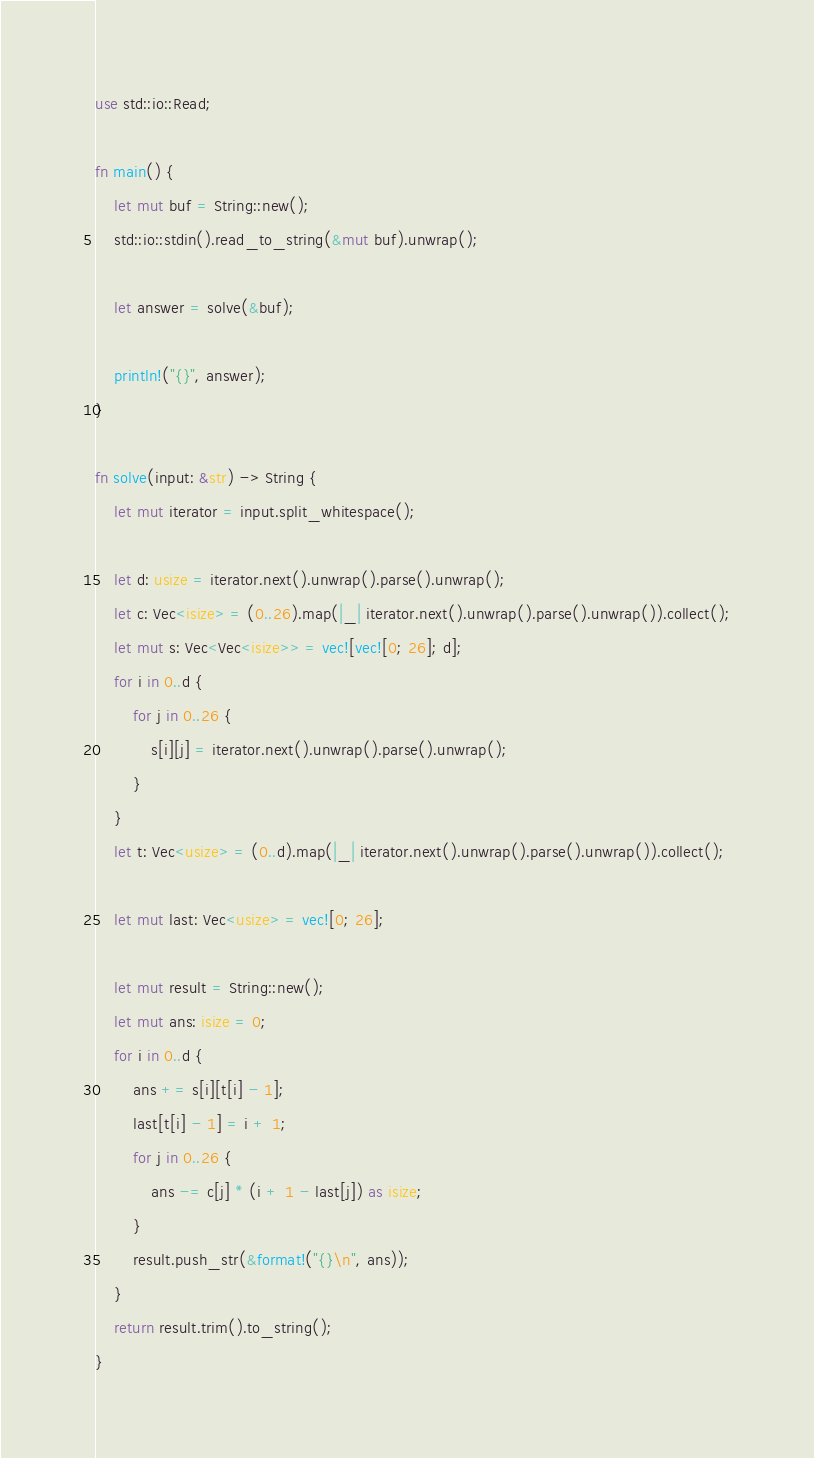Convert code to text. <code><loc_0><loc_0><loc_500><loc_500><_Rust_>use std::io::Read;

fn main() {
    let mut buf = String::new();
    std::io::stdin().read_to_string(&mut buf).unwrap();

    let answer = solve(&buf);

    println!("{}", answer);
}

fn solve(input: &str) -> String {
    let mut iterator = input.split_whitespace();

    let d: usize = iterator.next().unwrap().parse().unwrap();
    let c: Vec<isize> = (0..26).map(|_| iterator.next().unwrap().parse().unwrap()).collect();
    let mut s: Vec<Vec<isize>> = vec![vec![0; 26]; d];
    for i in 0..d {
        for j in 0..26 {
            s[i][j] = iterator.next().unwrap().parse().unwrap();
        }
    }
    let t: Vec<usize> = (0..d).map(|_| iterator.next().unwrap().parse().unwrap()).collect();

    let mut last: Vec<usize> = vec![0; 26];

    let mut result = String::new();
    let mut ans: isize = 0;
    for i in 0..d {
        ans += s[i][t[i] - 1];
        last[t[i] - 1] = i + 1;
        for j in 0..26 {
            ans -= c[j] * (i + 1 - last[j]) as isize;
        }
        result.push_str(&format!("{}\n", ans));
    }
    return result.trim().to_string();
}
</code> 